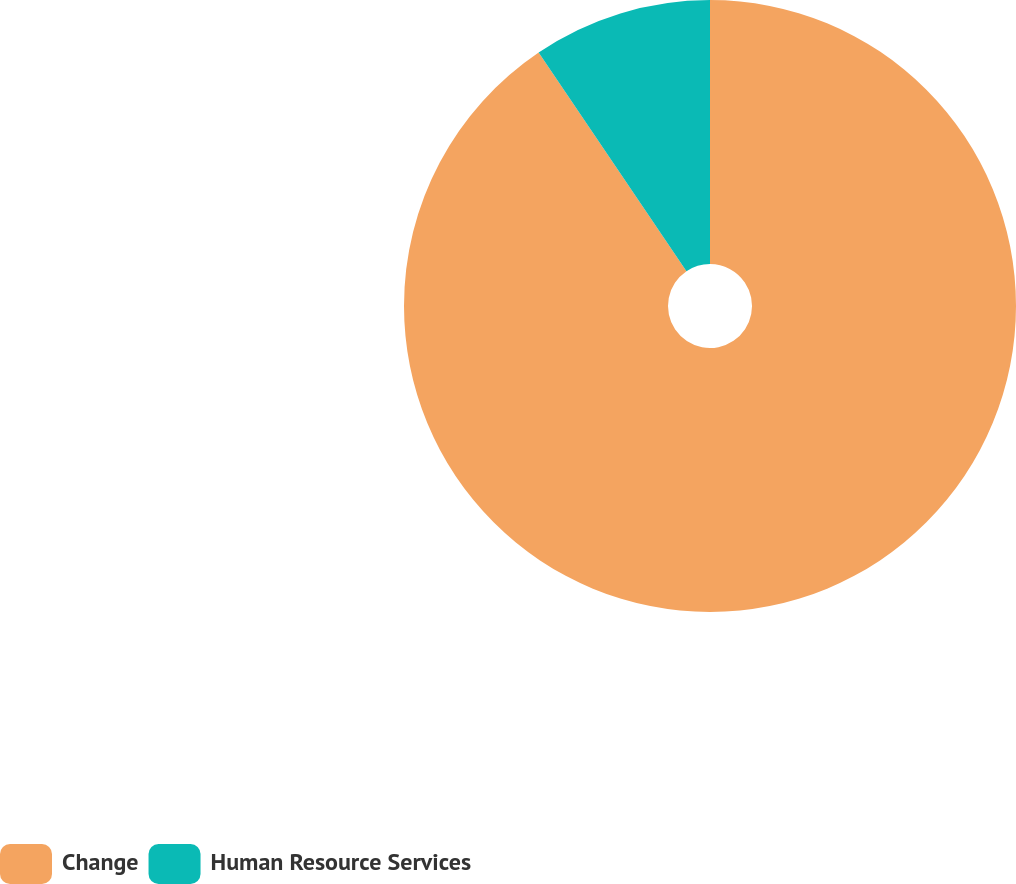<chart> <loc_0><loc_0><loc_500><loc_500><pie_chart><fcel>Change<fcel>Human Resource Services<nl><fcel>90.54%<fcel>9.46%<nl></chart> 